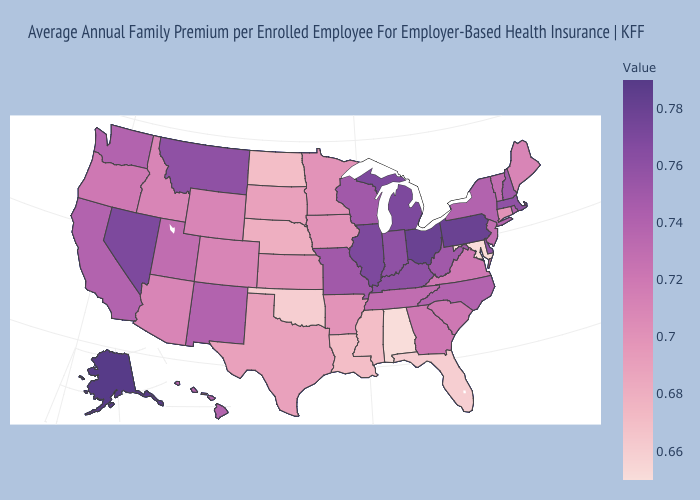Among the states that border Illinois , does Iowa have the lowest value?
Give a very brief answer. Yes. Which states have the highest value in the USA?
Be succinct. Alaska. Which states have the lowest value in the West?
Quick response, please. Arizona, Colorado, Idaho, Wyoming. Which states have the lowest value in the USA?
Give a very brief answer. Alabama, Maryland. Among the states that border New Hampshire , does Vermont have the highest value?
Give a very brief answer. No. 